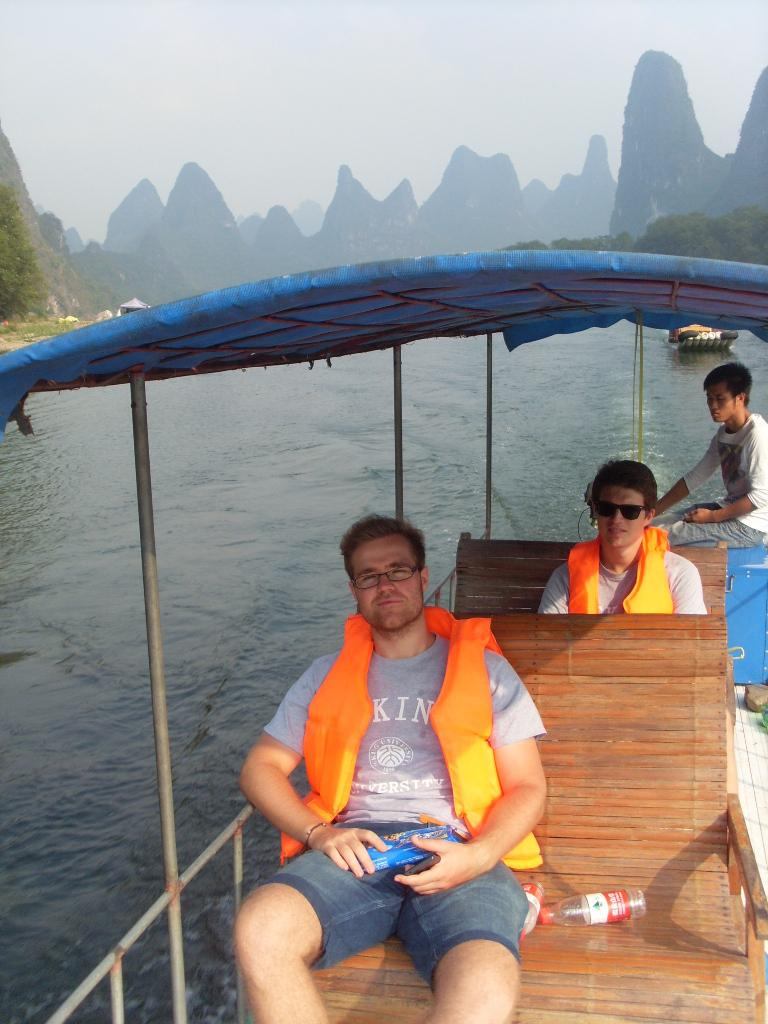What are the people in the image doing? The people in the image are sitting in a boat. Are any of the people in the boat wearing safety gear? Yes, two of the people are wearing life jackets. Are any of the people in the boat wearing glasses? Yes, two of the people are wearing spectacles. What can be seen in the background of the image? The image contains a river, trees, and the sky. What objects are visible in the boat? There are bottles visible in the image. What type of respect can be seen in the image? There is no specific type of respect visible in the image; it features people sitting in a boat. What country is depicted in the image? The image does not depict a specific country; it shows a river, trees, and the sky. 